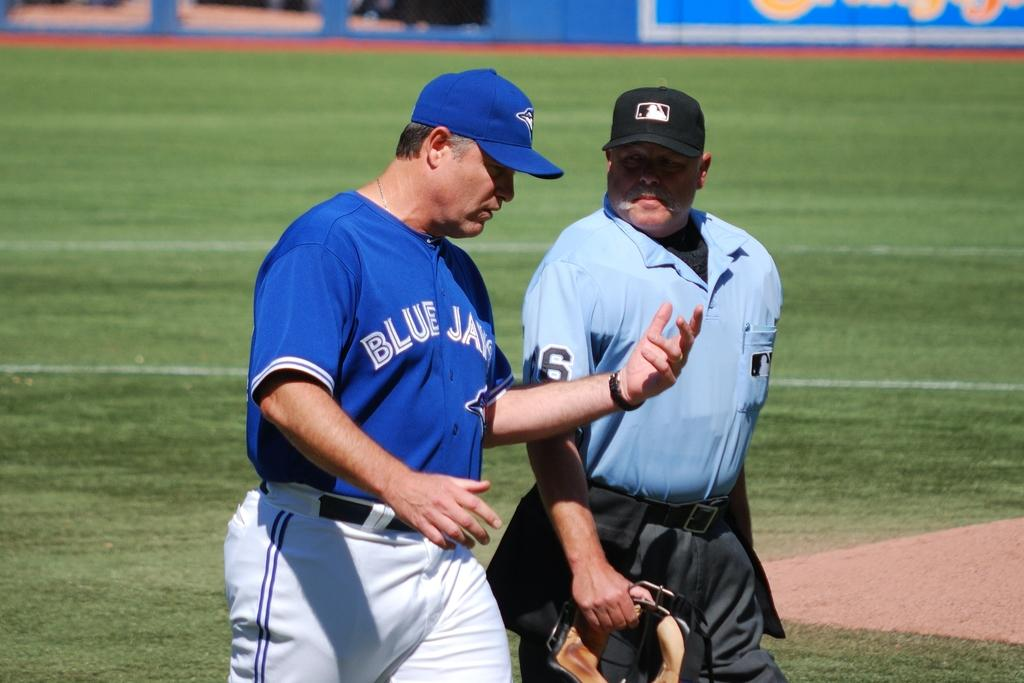<image>
Describe the image concisely. A Blue Jays manager has a conversation with an umpire wearing a number 6. 